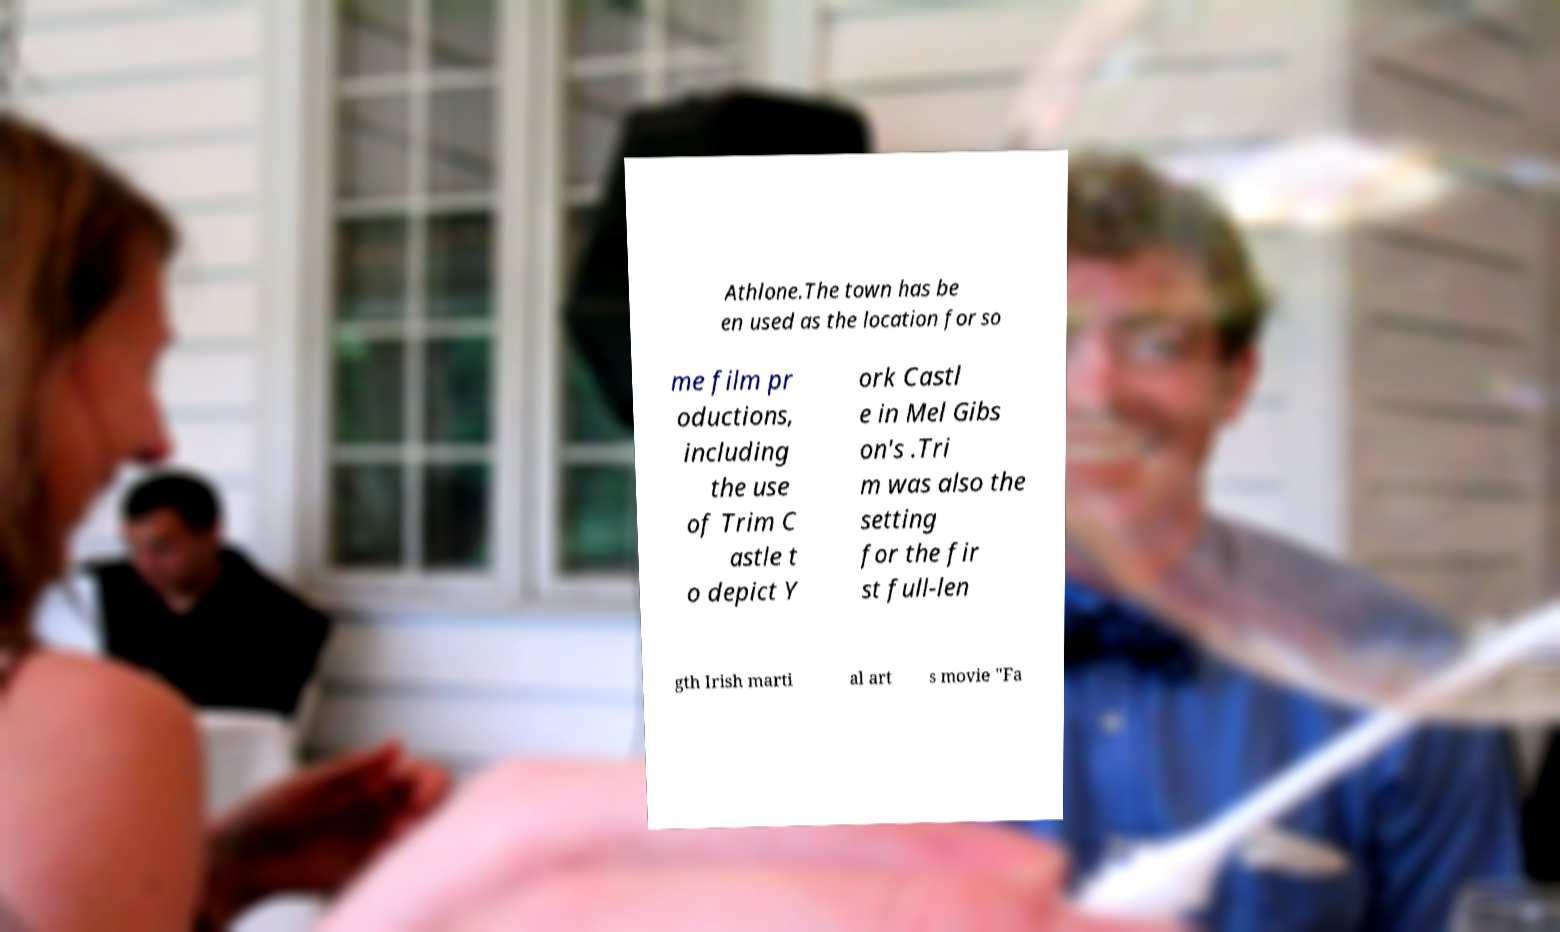Can you accurately transcribe the text from the provided image for me? Athlone.The town has be en used as the location for so me film pr oductions, including the use of Trim C astle t o depict Y ork Castl e in Mel Gibs on's .Tri m was also the setting for the fir st full-len gth Irish marti al art s movie "Fa 